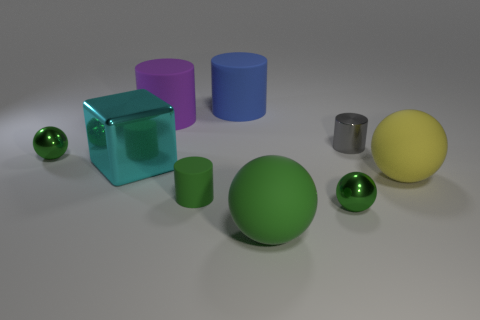Subtract all green balls. How many were subtracted if there are1green balls left? 2 Subtract all purple rubber cylinders. How many cylinders are left? 3 Subtract all cyan blocks. How many green balls are left? 3 Subtract all purple cylinders. How many cylinders are left? 3 Subtract 1 spheres. How many spheres are left? 3 Subtract all cubes. How many objects are left? 8 Add 2 tiny shiny spheres. How many tiny shiny spheres exist? 4 Subtract 1 green cylinders. How many objects are left? 8 Subtract all gray cubes. Subtract all gray balls. How many cubes are left? 1 Subtract all big yellow matte balls. Subtract all small cylinders. How many objects are left? 6 